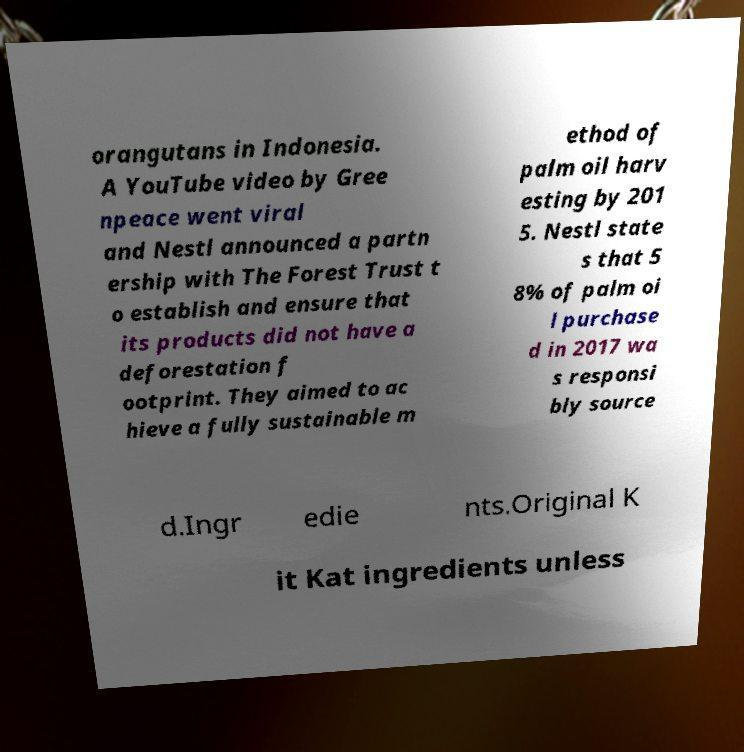Could you extract and type out the text from this image? orangutans in Indonesia. A YouTube video by Gree npeace went viral and Nestl announced a partn ership with The Forest Trust t o establish and ensure that its products did not have a deforestation f ootprint. They aimed to ac hieve a fully sustainable m ethod of palm oil harv esting by 201 5. Nestl state s that 5 8% of palm oi l purchase d in 2017 wa s responsi bly source d.Ingr edie nts.Original K it Kat ingredients unless 